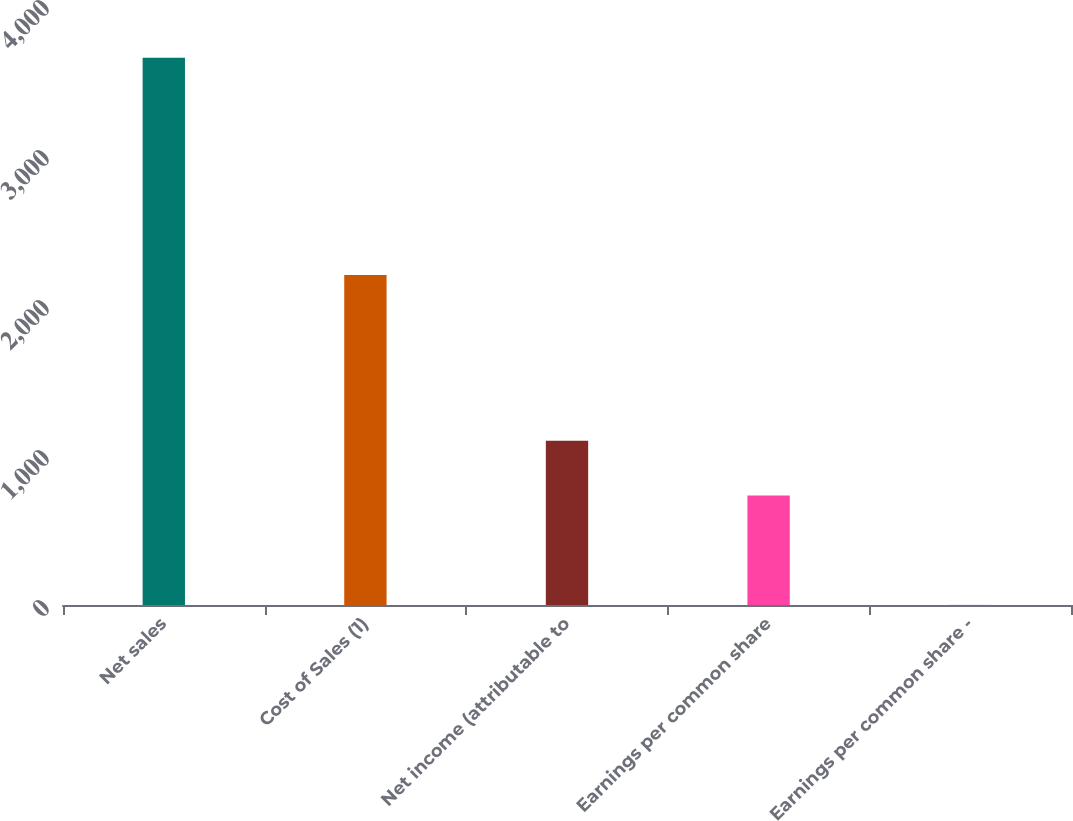<chart> <loc_0><loc_0><loc_500><loc_500><bar_chart><fcel>Net sales<fcel>Cost of Sales (1)<fcel>Net income (attributable to<fcel>Earnings per common share<fcel>Earnings per common share -<nl><fcel>3648<fcel>2200<fcel>1095.37<fcel>730.71<fcel>1.39<nl></chart> 